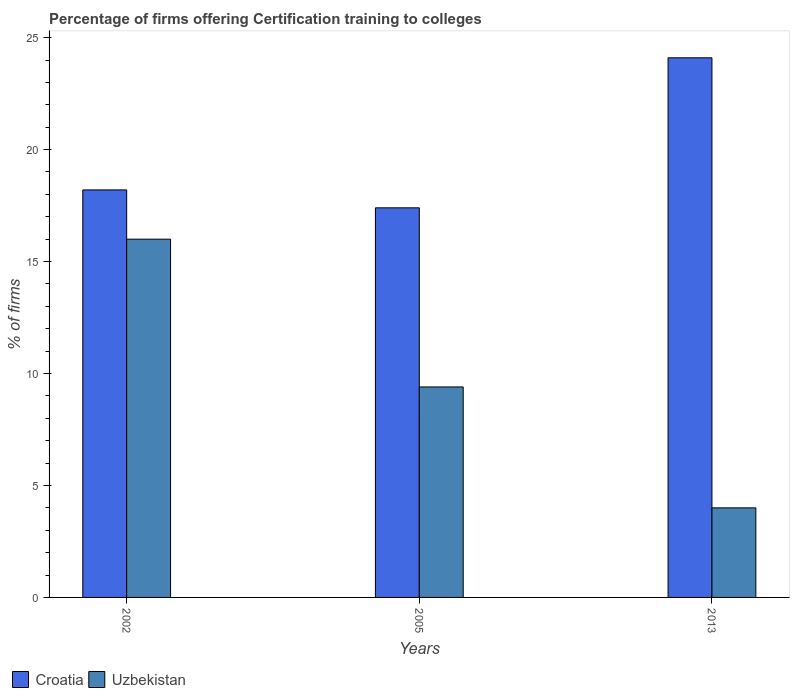How many groups of bars are there?
Your response must be concise. 3. How many bars are there on the 3rd tick from the left?
Keep it short and to the point. 2. How many bars are there on the 2nd tick from the right?
Offer a very short reply. 2. In which year was the percentage of firms offering certification training to colleges in Croatia maximum?
Ensure brevity in your answer.  2013. In which year was the percentage of firms offering certification training to colleges in Croatia minimum?
Make the answer very short. 2005. What is the total percentage of firms offering certification training to colleges in Uzbekistan in the graph?
Your response must be concise. 29.4. What is the difference between the percentage of firms offering certification training to colleges in Croatia in 2005 and that in 2013?
Ensure brevity in your answer.  -6.7. What is the difference between the percentage of firms offering certification training to colleges in Croatia in 2005 and the percentage of firms offering certification training to colleges in Uzbekistan in 2013?
Provide a short and direct response. 13.4. What is the average percentage of firms offering certification training to colleges in Uzbekistan per year?
Give a very brief answer. 9.8. In the year 2002, what is the difference between the percentage of firms offering certification training to colleges in Uzbekistan and percentage of firms offering certification training to colleges in Croatia?
Keep it short and to the point. -2.2. What is the ratio of the percentage of firms offering certification training to colleges in Uzbekistan in 2005 to that in 2013?
Make the answer very short. 2.35. Is the difference between the percentage of firms offering certification training to colleges in Uzbekistan in 2002 and 2013 greater than the difference between the percentage of firms offering certification training to colleges in Croatia in 2002 and 2013?
Provide a short and direct response. Yes. What is the difference between the highest and the second highest percentage of firms offering certification training to colleges in Croatia?
Make the answer very short. 5.9. What is the difference between the highest and the lowest percentage of firms offering certification training to colleges in Croatia?
Offer a terse response. 6.7. Is the sum of the percentage of firms offering certification training to colleges in Croatia in 2002 and 2013 greater than the maximum percentage of firms offering certification training to colleges in Uzbekistan across all years?
Your answer should be compact. Yes. What does the 2nd bar from the left in 2005 represents?
Provide a succinct answer. Uzbekistan. What does the 2nd bar from the right in 2002 represents?
Offer a terse response. Croatia. How many bars are there?
Keep it short and to the point. 6. How many years are there in the graph?
Your answer should be compact. 3. Are the values on the major ticks of Y-axis written in scientific E-notation?
Your answer should be very brief. No. How many legend labels are there?
Make the answer very short. 2. How are the legend labels stacked?
Offer a terse response. Horizontal. What is the title of the graph?
Provide a short and direct response. Percentage of firms offering Certification training to colleges. What is the label or title of the Y-axis?
Provide a short and direct response. % of firms. What is the % of firms of Croatia in 2005?
Keep it short and to the point. 17.4. What is the % of firms in Uzbekistan in 2005?
Your answer should be compact. 9.4. What is the % of firms in Croatia in 2013?
Make the answer very short. 24.1. Across all years, what is the maximum % of firms of Croatia?
Your answer should be very brief. 24.1. Across all years, what is the maximum % of firms of Uzbekistan?
Ensure brevity in your answer.  16. Across all years, what is the minimum % of firms of Croatia?
Offer a terse response. 17.4. Across all years, what is the minimum % of firms of Uzbekistan?
Offer a terse response. 4. What is the total % of firms of Croatia in the graph?
Ensure brevity in your answer.  59.7. What is the total % of firms in Uzbekistan in the graph?
Keep it short and to the point. 29.4. What is the difference between the % of firms in Croatia in 2002 and that in 2013?
Your response must be concise. -5.9. What is the difference between the % of firms of Uzbekistan in 2002 and that in 2013?
Make the answer very short. 12. What is the difference between the % of firms in Uzbekistan in 2005 and that in 2013?
Ensure brevity in your answer.  5.4. What is the average % of firms in Croatia per year?
Offer a terse response. 19.9. What is the average % of firms of Uzbekistan per year?
Keep it short and to the point. 9.8. In the year 2002, what is the difference between the % of firms in Croatia and % of firms in Uzbekistan?
Make the answer very short. 2.2. In the year 2013, what is the difference between the % of firms in Croatia and % of firms in Uzbekistan?
Provide a succinct answer. 20.1. What is the ratio of the % of firms in Croatia in 2002 to that in 2005?
Your response must be concise. 1.05. What is the ratio of the % of firms in Uzbekistan in 2002 to that in 2005?
Your answer should be very brief. 1.7. What is the ratio of the % of firms of Croatia in 2002 to that in 2013?
Your answer should be compact. 0.76. What is the ratio of the % of firms of Uzbekistan in 2002 to that in 2013?
Ensure brevity in your answer.  4. What is the ratio of the % of firms of Croatia in 2005 to that in 2013?
Offer a very short reply. 0.72. What is the ratio of the % of firms in Uzbekistan in 2005 to that in 2013?
Offer a very short reply. 2.35. What is the difference between the highest and the second highest % of firms in Croatia?
Your response must be concise. 5.9. What is the difference between the highest and the second highest % of firms in Uzbekistan?
Your response must be concise. 6.6. What is the difference between the highest and the lowest % of firms in Croatia?
Provide a short and direct response. 6.7. What is the difference between the highest and the lowest % of firms in Uzbekistan?
Offer a very short reply. 12. 